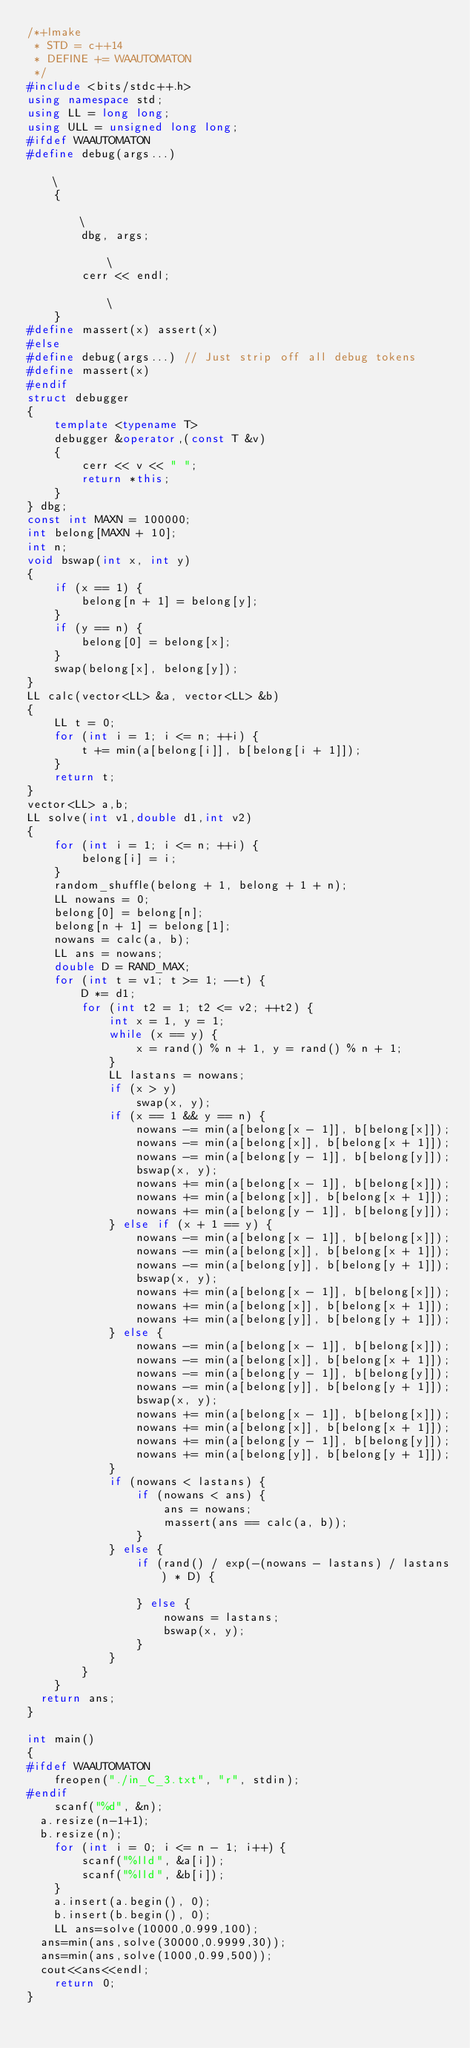Convert code to text. <code><loc_0><loc_0><loc_500><loc_500><_C++_>/*+lmake
 * STD = c++14
 * DEFINE += WAAUTOMATON
 */
#include <bits/stdc++.h>
using namespace std;
using LL = long long;
using ULL = unsigned long long;
#ifdef WAAUTOMATON
#define debug(args...)                                                                             \
    {                                                                                              \
        dbg, args;                                                                                 \
        cerr << endl;                                                                              \
    }
#define massert(x) assert(x)
#else
#define debug(args...) // Just strip off all debug tokens
#define massert(x)
#endif
struct debugger
{
    template <typename T>
    debugger &operator,(const T &v)
    {
        cerr << v << " ";
        return *this;
    }
} dbg;
const int MAXN = 100000;
int belong[MAXN + 10];
int n;
void bswap(int x, int y)
{
    if (x == 1) {
        belong[n + 1] = belong[y];
    }
    if (y == n) {
        belong[0] = belong[x];
    }
    swap(belong[x], belong[y]);
}
LL calc(vector<LL> &a, vector<LL> &b)
{
    LL t = 0;
    for (int i = 1; i <= n; ++i) {
        t += min(a[belong[i]], b[belong[i + 1]]);
    }
    return t;
}
vector<LL> a,b;
LL solve(int v1,double d1,int v2)
{
    for (int i = 1; i <= n; ++i) {
        belong[i] = i;
    }
    random_shuffle(belong + 1, belong + 1 + n);
    LL nowans = 0;
    belong[0] = belong[n];
    belong[n + 1] = belong[1];
    nowans = calc(a, b);
    LL ans = nowans;
    double D = RAND_MAX;
    for (int t = v1; t >= 1; --t) {
        D *= d1;
        for (int t2 = 1; t2 <= v2; ++t2) {
            int x = 1, y = 1;
            while (x == y) {
                x = rand() % n + 1, y = rand() % n + 1;
            }
            LL lastans = nowans;
            if (x > y)
                swap(x, y);
            if (x == 1 && y == n) {
                nowans -= min(a[belong[x - 1]], b[belong[x]]);
                nowans -= min(a[belong[x]], b[belong[x + 1]]);
                nowans -= min(a[belong[y - 1]], b[belong[y]]);
                bswap(x, y);
                nowans += min(a[belong[x - 1]], b[belong[x]]);
                nowans += min(a[belong[x]], b[belong[x + 1]]);
                nowans += min(a[belong[y - 1]], b[belong[y]]);
            } else if (x + 1 == y) {
                nowans -= min(a[belong[x - 1]], b[belong[x]]);
                nowans -= min(a[belong[x]], b[belong[x + 1]]);
                nowans -= min(a[belong[y]], b[belong[y + 1]]);
                bswap(x, y);
                nowans += min(a[belong[x - 1]], b[belong[x]]);
                nowans += min(a[belong[x]], b[belong[x + 1]]);
                nowans += min(a[belong[y]], b[belong[y + 1]]);
            } else {
                nowans -= min(a[belong[x - 1]], b[belong[x]]);
                nowans -= min(a[belong[x]], b[belong[x + 1]]);
                nowans -= min(a[belong[y - 1]], b[belong[y]]);
                nowans -= min(a[belong[y]], b[belong[y + 1]]);
                bswap(x, y);
                nowans += min(a[belong[x - 1]], b[belong[x]]);
                nowans += min(a[belong[x]], b[belong[x + 1]]);
                nowans += min(a[belong[y - 1]], b[belong[y]]);
                nowans += min(a[belong[y]], b[belong[y + 1]]);
            }
            if (nowans < lastans) {
                if (nowans < ans) {
                    ans = nowans;
                    massert(ans == calc(a, b));
                }
            } else {
                if (rand() / exp(-(nowans - lastans) / lastans) * D) {

                } else {
                    nowans = lastans;
                    bswap(x, y);
                }
            }
        }
    }
	return ans;
}

int main()
{
#ifdef WAAUTOMATON
    freopen("./in_C_3.txt", "r", stdin);
#endif
    scanf("%d", &n);
	a.resize(n-1+1);
	b.resize(n);
    for (int i = 0; i <= n - 1; i++) {
        scanf("%lld", &a[i]);
        scanf("%lld", &b[i]);
    }
    a.insert(a.begin(), 0);
    b.insert(b.begin(), 0);
    LL ans=solve(10000,0.999,100);
	ans=min(ans,solve(30000,0.9999,30));
	ans=min(ans,solve(1000,0.99,500));
	cout<<ans<<endl;
    return 0;
}
</code> 